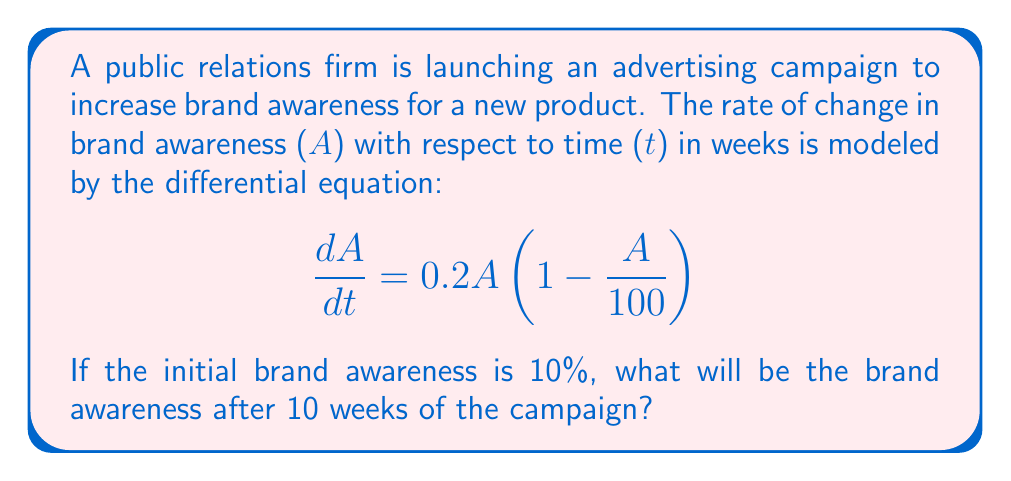Teach me how to tackle this problem. To solve this problem, we need to use the given first-order differential equation and apply the initial condition. This is a logistic growth model, which is commonly used in marketing to model the spread of awareness or adoption of a product.

1. The given differential equation is:
   $$\frac{dA}{dt} = 0.2A(1 - \frac{A}{100})$$

2. This is a separable differential equation. We can solve it by separating variables:
   $$\frac{dA}{A(1 - \frac{A}{100})} = 0.2dt$$

3. Integrating both sides:
   $$\int \frac{dA}{A(1 - \frac{A}{100})} = \int 0.2dt$$

4. The left side can be integrated using partial fractions:
   $$\ln|A| - \ln|100-A| = 0.2t + C$$

5. Simplifying and applying the exponential function to both sides:
   $$\frac{A}{100-A} = Ce^{0.2t}$$

6. Solving for A:
   $$A = \frac{100Ce^{0.2t}}{1 + Ce^{0.2t}}$$

7. Using the initial condition A(0) = 10, we can find C:
   $$10 = \frac{100C}{1 + C}$$
   $$C = \frac{1}{9}$$

8. Substituting this back into our solution:
   $$A = \frac{100(\frac{1}{9})e^{0.2t}}{1 + (\frac{1}{9})e^{0.2t}} = \frac{100}{9e^{-0.2t} + 1}$$

9. To find A(10), we substitute t = 10:
   $$A(10) = \frac{100}{9e^{-2} + 1} \approx 73.11$$

Therefore, after 10 weeks, the brand awareness will be approximately 73.11%.
Answer: After 10 weeks of the advertising campaign, the brand awareness will be approximately 73.11%. 